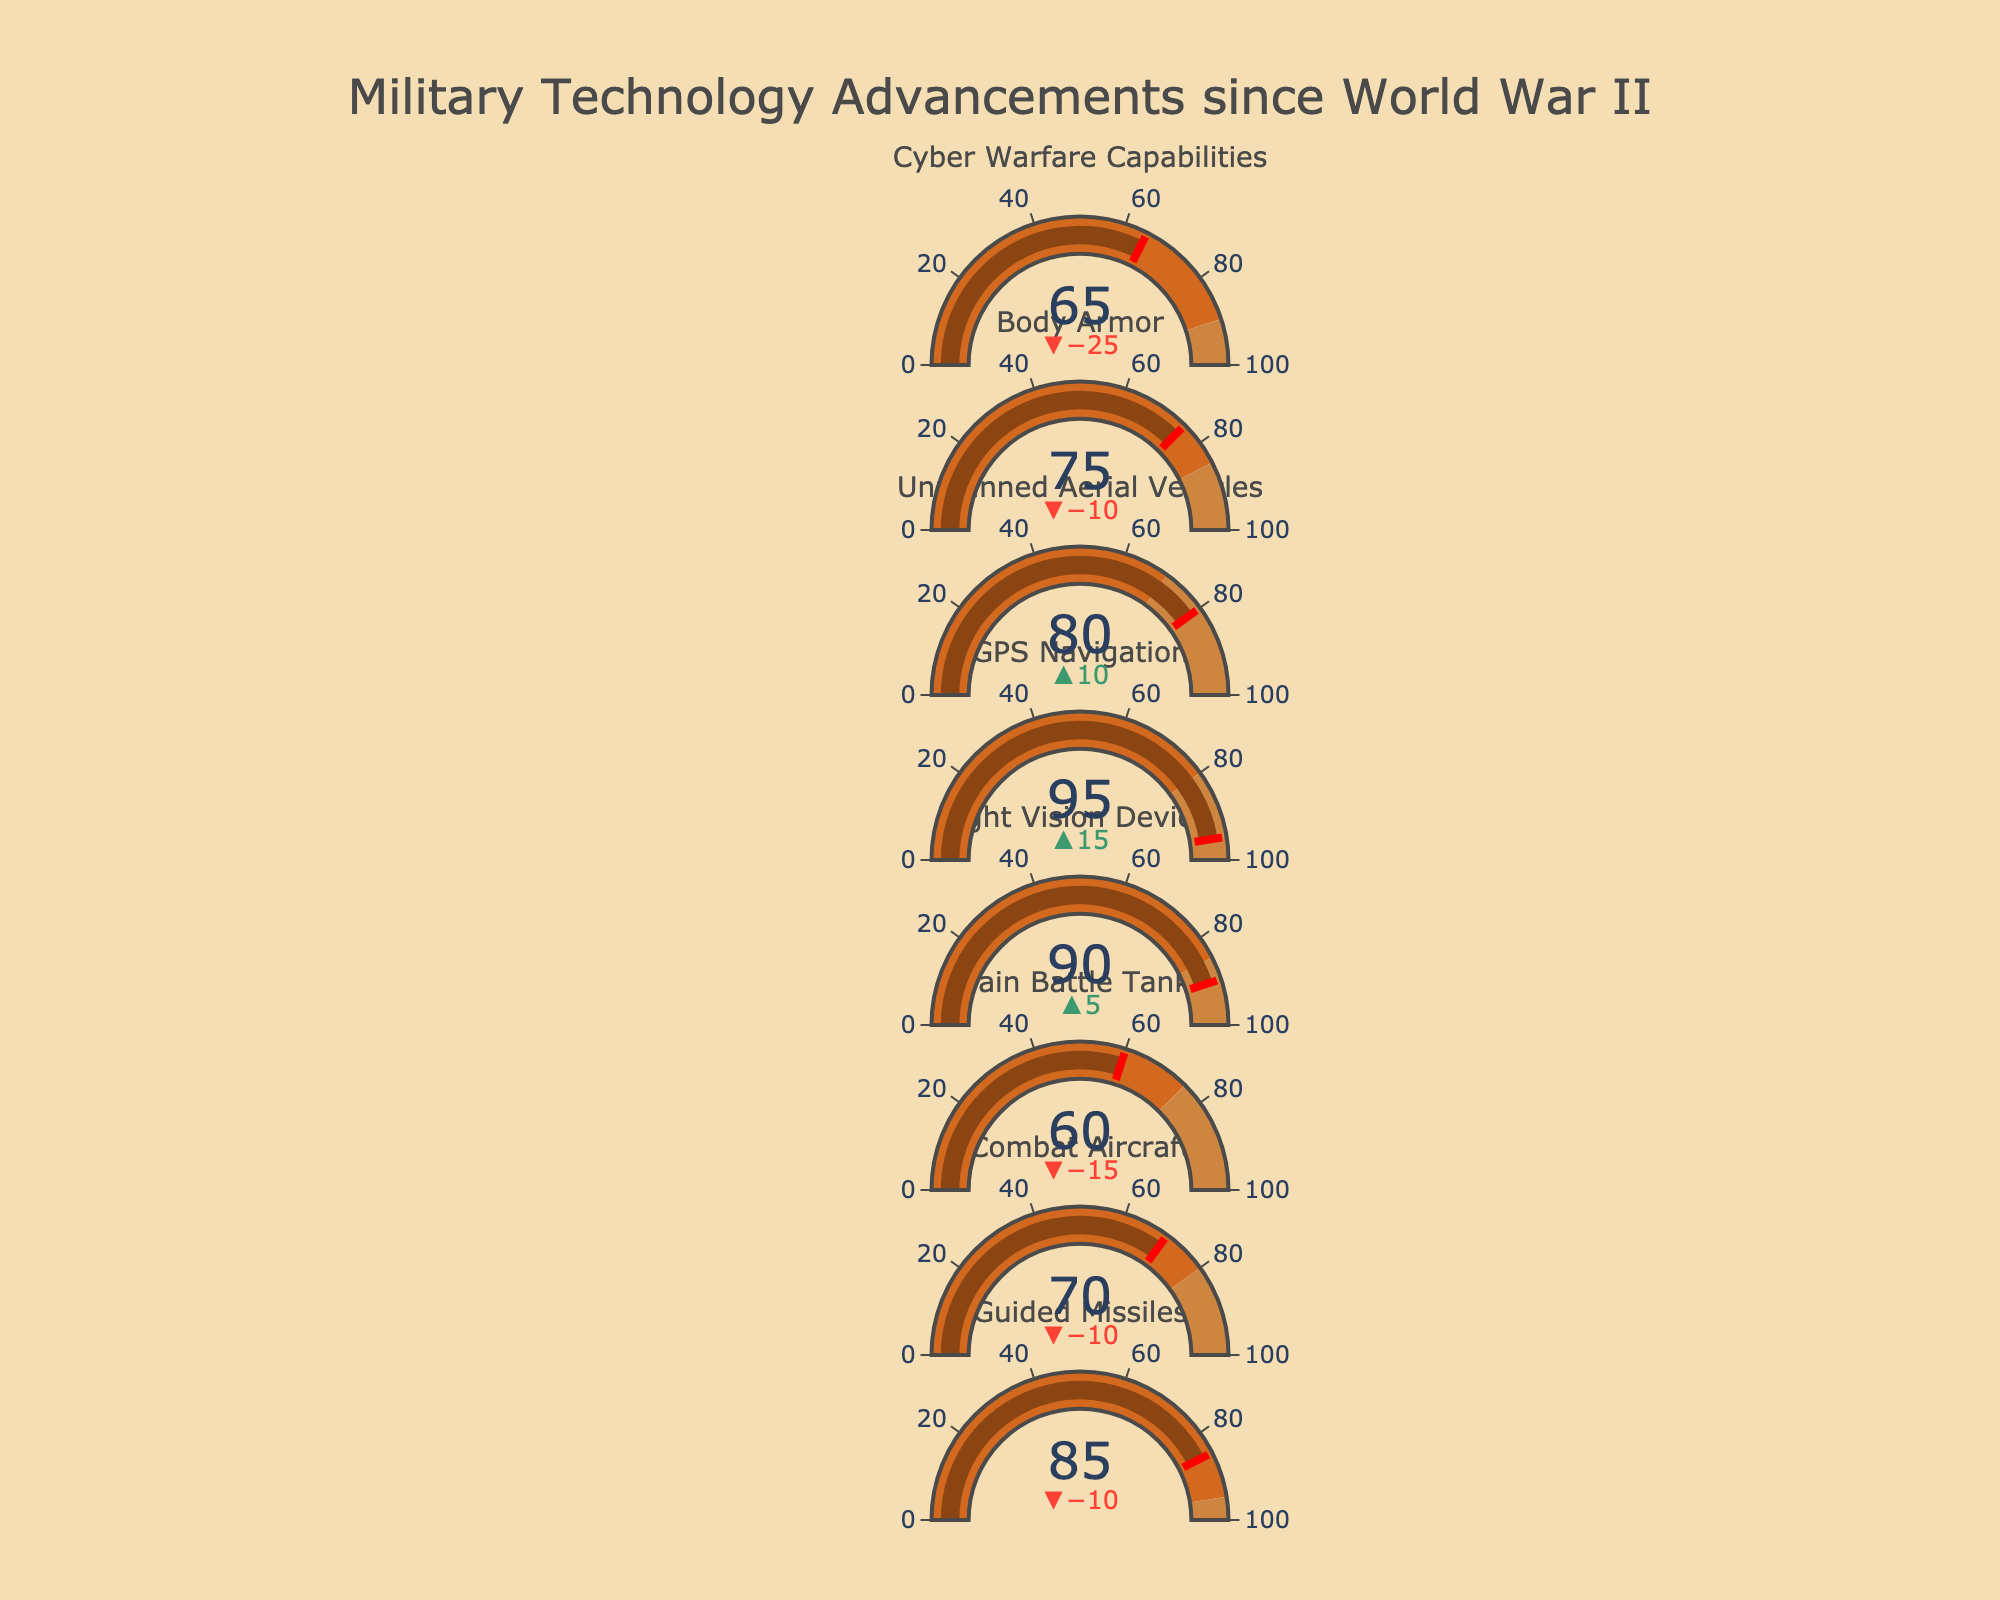What is the title of the chart? The title is usually at the top of the chart and stated explicitly. The title of the chart is "Military Technology Advancements since World War II".
Answer: Military Technology Advancements since World War II How many categories of military technology advancements are shown? By counting the individual sections or indicators on the bullet chart, we can determine the number of categories. There are 8 categories depicted in the chart.
Answer: 8 Which category has the highest actual value? To determine this, we examine the actual values for each category shown by the bullet gauges. GPS Navigation has the highest value at 95.
Answer: GPS Navigation What is the difference between the planned and actual values for Body Armor? The planned value for Body Armor is 85, and the actual value is 75. The difference can be calculated as 85 - 75 = 10.
Answer: 10 Which category exceeded its planned development milestone? We need to identify categories where the actual value is greater than the planned value. Night Vision Devices (90 vs 85) and GPS Navigation (95 vs 80) are the categories that exceeded their planned values.
Answer: Night Vision Devices, GPS Navigation What is the sum of the planned values for Guided Missiles and Combat Aircraft? Adding the planned values for Guided Missiles (95) and Combat Aircraft (80), we get 95 + 80 = 175.
Answer: 175 Which category has the smallest difference between planned and actual values? We calculate the differences for each category. Guided Missiles (10), Combat Aircraft (10), Main Battle Tanks (15), Night Vision Devices (-5), GPS Navigation (-15), Unmanned Aerial Vehicles (10), Body Armor (10), Cyber Warfare Capabilities (25). The smallest absolute difference is for Night Vision Devices at 5.
Answer: Night Vision Devices What percentage of the maximum value does the actual value for Main Battle Tanks represent? To find this, divide the actual value (60) by the maximum value (100) and multiply by 100. (60/100) * 100 = 60%.
Answer: 60% Which two categories have the same number of planned vs actual difference? By examining the differences calculated earlier, Guided Missiles, Combat Aircraft, Unmanned Aerial Vehicles, and Body Armor each have a difference of 10.
Answer: Guided Missiles, Combat Aircraft, Unmanned Aerial Vehicles, Body Armor What's the average actual value of all categories? Sum all the actual values and divide by the number of categories: (85 + 70 + 60 + 90 + 95 + 80 + 75 + 65) / 8 = 77.5.
Answer: 77.5 